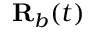Convert formula to latex. <formula><loc_0><loc_0><loc_500><loc_500>R _ { b } ( t )</formula> 